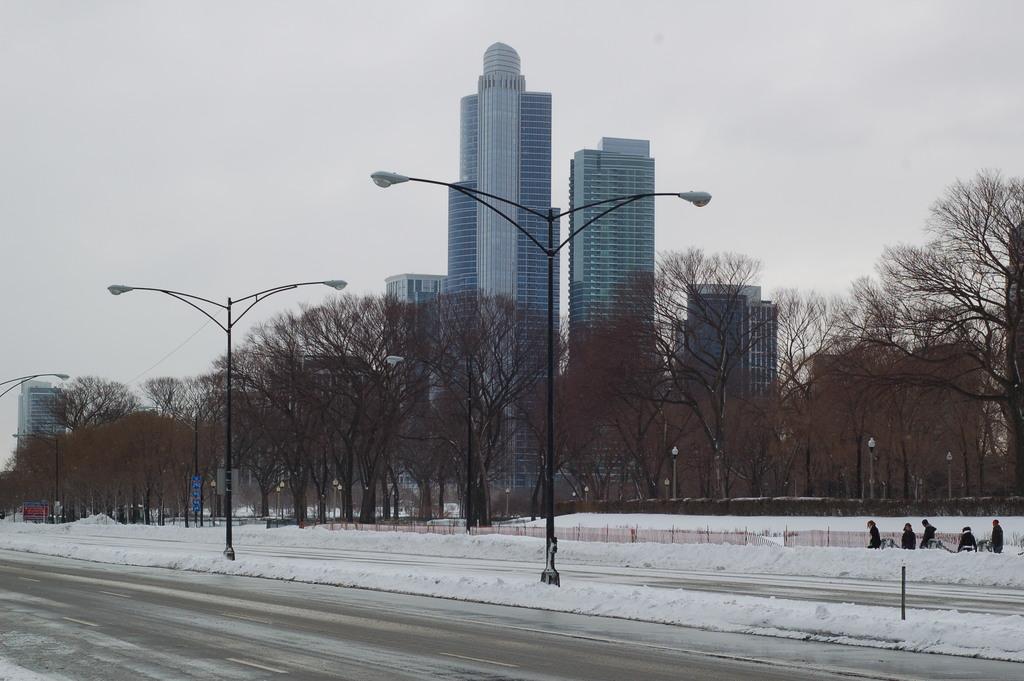Can you describe this image briefly? In the foreground of this image, there are street lights placed side to the road. In the background, there are buildings, trees, persons walking on the snow and the sky. 